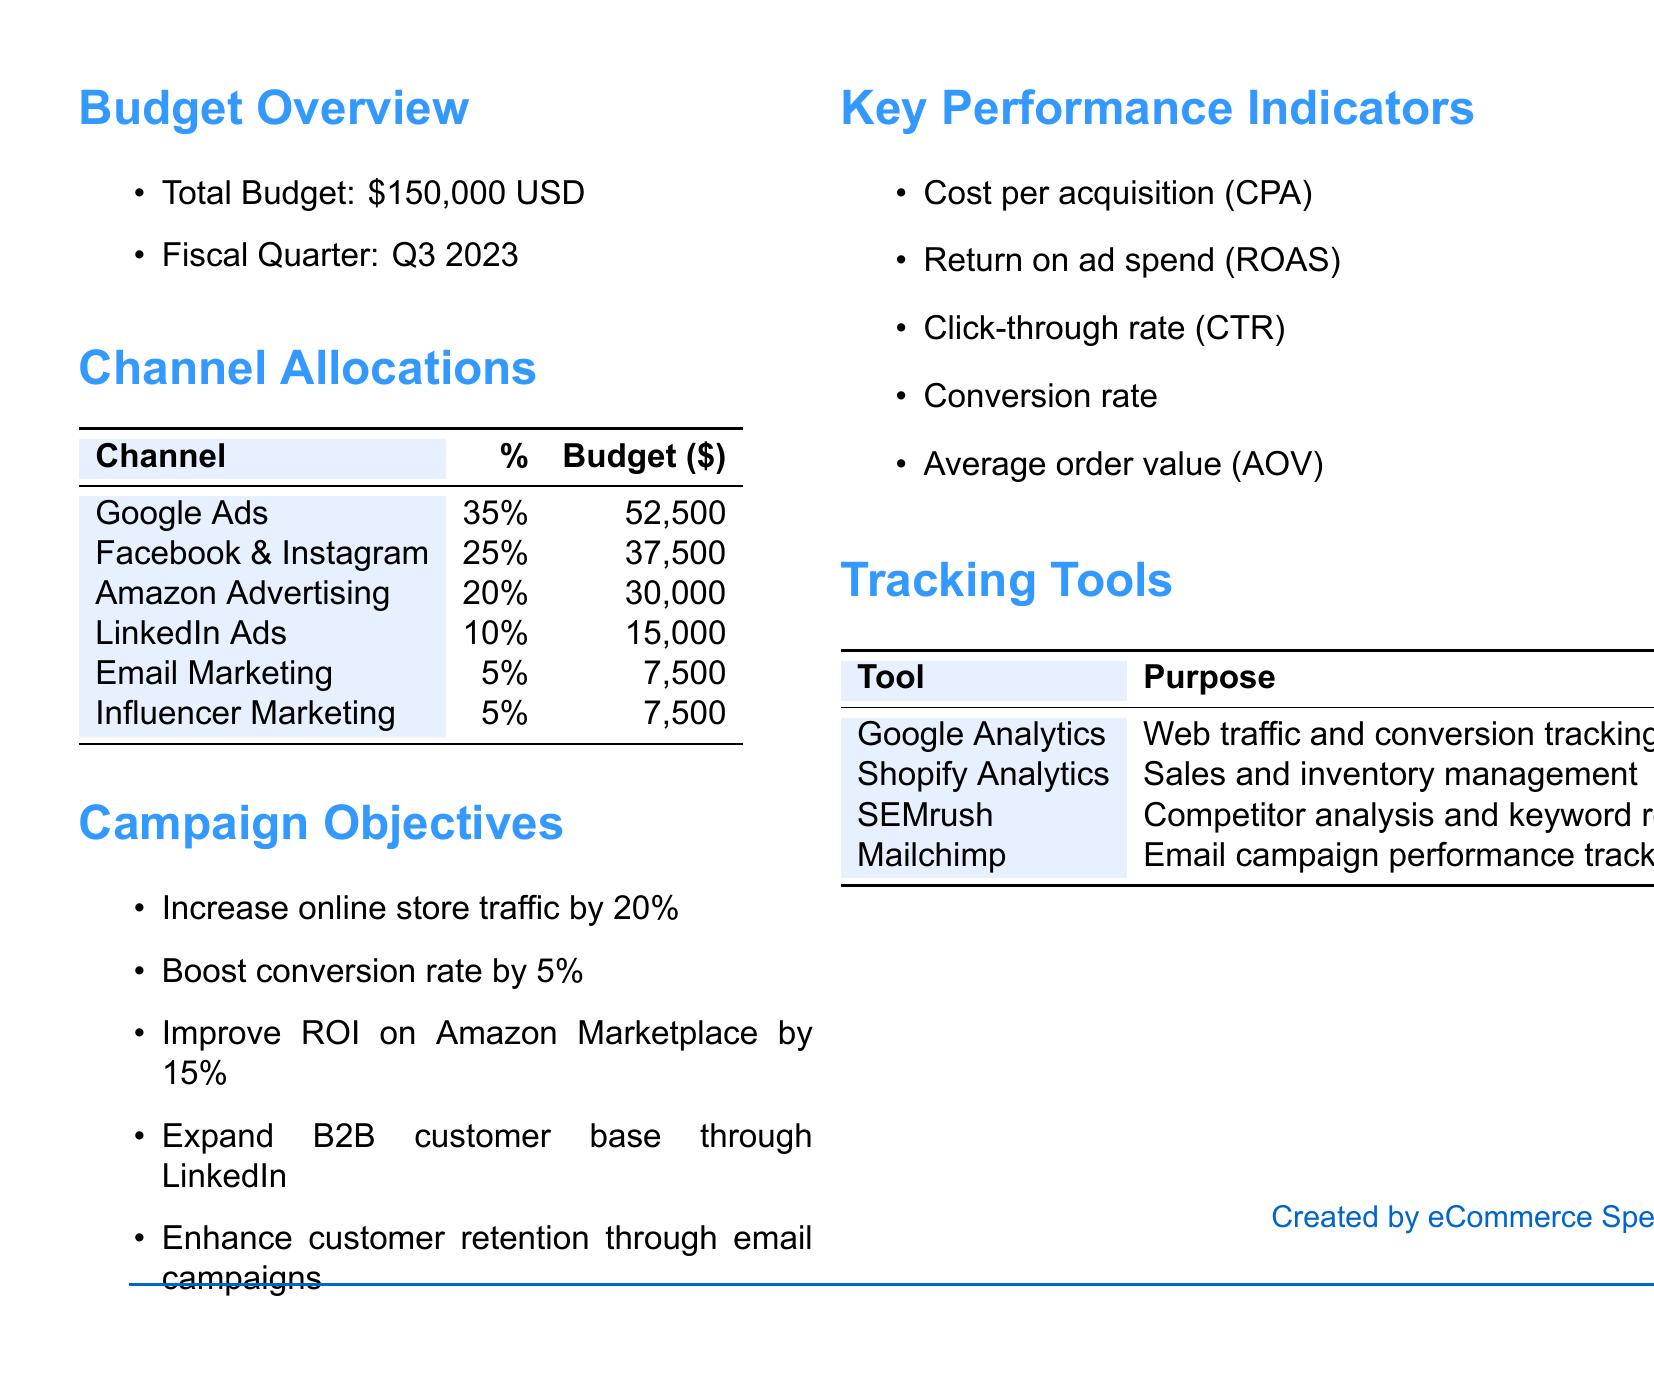What is the total budget for Q3 2023? The total budget is stated clearly at the beginning of the document, which is $150,000.
Answer: $150,000 What percentage of the budget is allocated to Google Ads? Google Ads is allocated a percentage that is specified in the channel allocations section of the document, which is 35%.
Answer: 35% How much is allocated to Facebook & Instagram? The budget allocation specific to Facebook & Instagram is listed in the channel allocations table, which is $37,500.
Answer: $37,500 What is the objective related to online store traffic? The objective states an increase of online store traffic that is mentioned in the campaign objectives section as a 20% increase.
Answer: 20% Which tracking tool is used for email campaign performance tracking? The tool specified for email campaign performance tracking is mentioned under the tracking tools section, and that tool is Mailchimp.
Answer: Mailchimp What is the expected improvement in the ROI on Amazon Marketplace? The expected improvement is stated in the campaign objectives section, which is a 15% increase.
Answer: 15% How many channels are listed for budget allocation? The number of channels can be counted from the channel allocations table, which lists 6 different channels.
Answer: 6 What is the budget allocated for LinkedIn Ads? The budget for LinkedIn Ads is directly provided in the channel allocations table, which is $15,000.
Answer: $15,000 What is the goal related to customer retention? The goal related to customer retention is mentioned in the campaign objectives, which is to enhance customer retention.
Answer: Enhance customer retention 